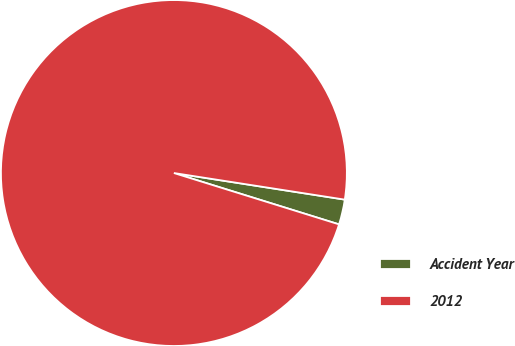Convert chart to OTSL. <chart><loc_0><loc_0><loc_500><loc_500><pie_chart><fcel>Accident Year<fcel>2012<nl><fcel>2.34%<fcel>97.66%<nl></chart> 